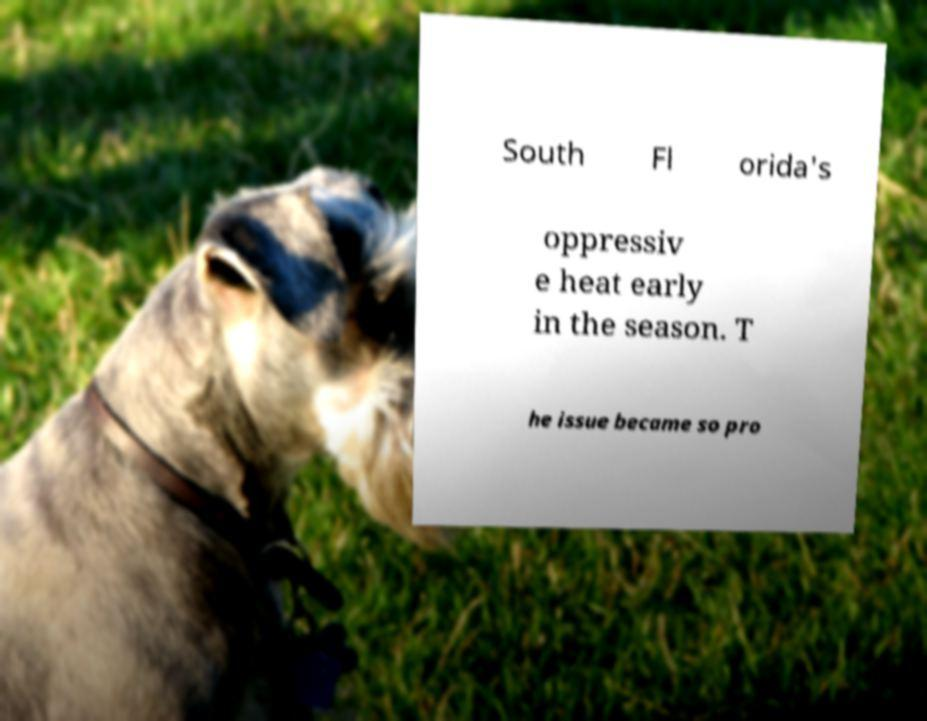What messages or text are displayed in this image? I need them in a readable, typed format. South Fl orida's oppressiv e heat early in the season. T he issue became so pro 